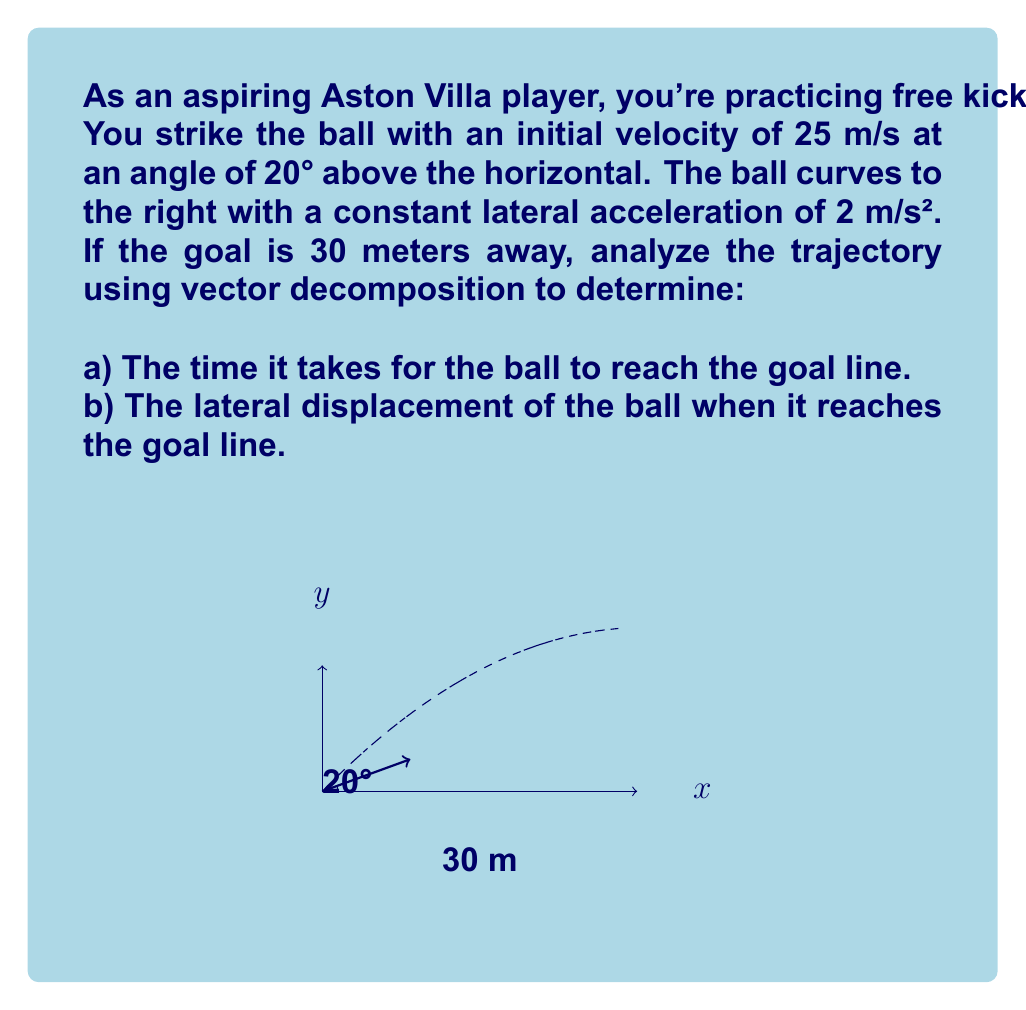Can you solve this math problem? Let's approach this problem step-by-step using vector decomposition:

1) First, let's decompose the initial velocity into x and y components:

   $v_x = v \cos \theta = 25 \cos 20° \approx 23.49$ m/s
   $v_y = v \sin \theta = 25 \sin 20° \approx 8.55$ m/s

2) The time to reach the goal can be calculated using the x-component of motion:

   $x = v_x t$
   $30 = 23.49t$
   $t = \frac{30}{23.49} \approx 1.28$ seconds

3) Now, let's consider the lateral motion (z-direction). The displacement due to constant acceleration is given by:

   $z = \frac{1}{2}a_z t^2$

   where $a_z = 2$ m/s² (given lateral acceleration)

4) Substituting the time we calculated:

   $z = \frac{1}{2} \cdot 2 \cdot (1.28)^2 \approx 1.64$ meters

Therefore, when the ball reaches the goal line after 1.28 seconds, it will have curved 1.64 meters to the right.

5) As a verification, we can calculate the y-position of the ball when it reaches the goal:

   $y = v_y t - \frac{1}{2}gt^2$
   $y = 8.55 \cdot 1.28 - \frac{1}{2} \cdot 9.8 \cdot (1.28)^2 \approx 5.47$ meters

This confirms that the ball is still above the ground when it reaches the goal line.
Answer: a) 1.28 seconds
b) 1.64 meters 